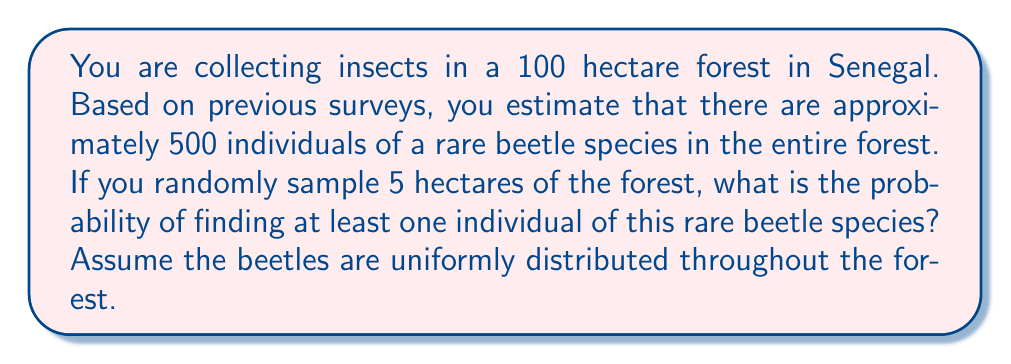Teach me how to tackle this problem. Let's approach this step-by-step using the binomial probability distribution:

1) First, we need to calculate the probability of finding a beetle in a single hectare:
   $p = \frac{500 \text{ beetles}}{100 \text{ hectares}} = 5 \text{ beetles per hectare}$

2) The probability of not finding a beetle in one hectare is:
   $1 - p = 1 - 5/100 = 0.95$

3) We are sampling 5 hectares, so the probability of not finding any beetles in all 5 hectares is:
   $(0.95)^5 = 0.7738$

4) Therefore, the probability of finding at least one beetle is the complement of this:
   $1 - (0.95)^5 = 1 - 0.7738 = 0.2262$

5) We can express this using the binomial probability formula:

   $$P(X \geq 1) = 1 - P(X = 0) = 1 - \binom{5}{0} (0.05)^0 (0.95)^5 = 0.2262$$

   Where $X$ is the number of hectares containing at least one beetle.
Answer: $0.2262$ or $22.62\%$ 